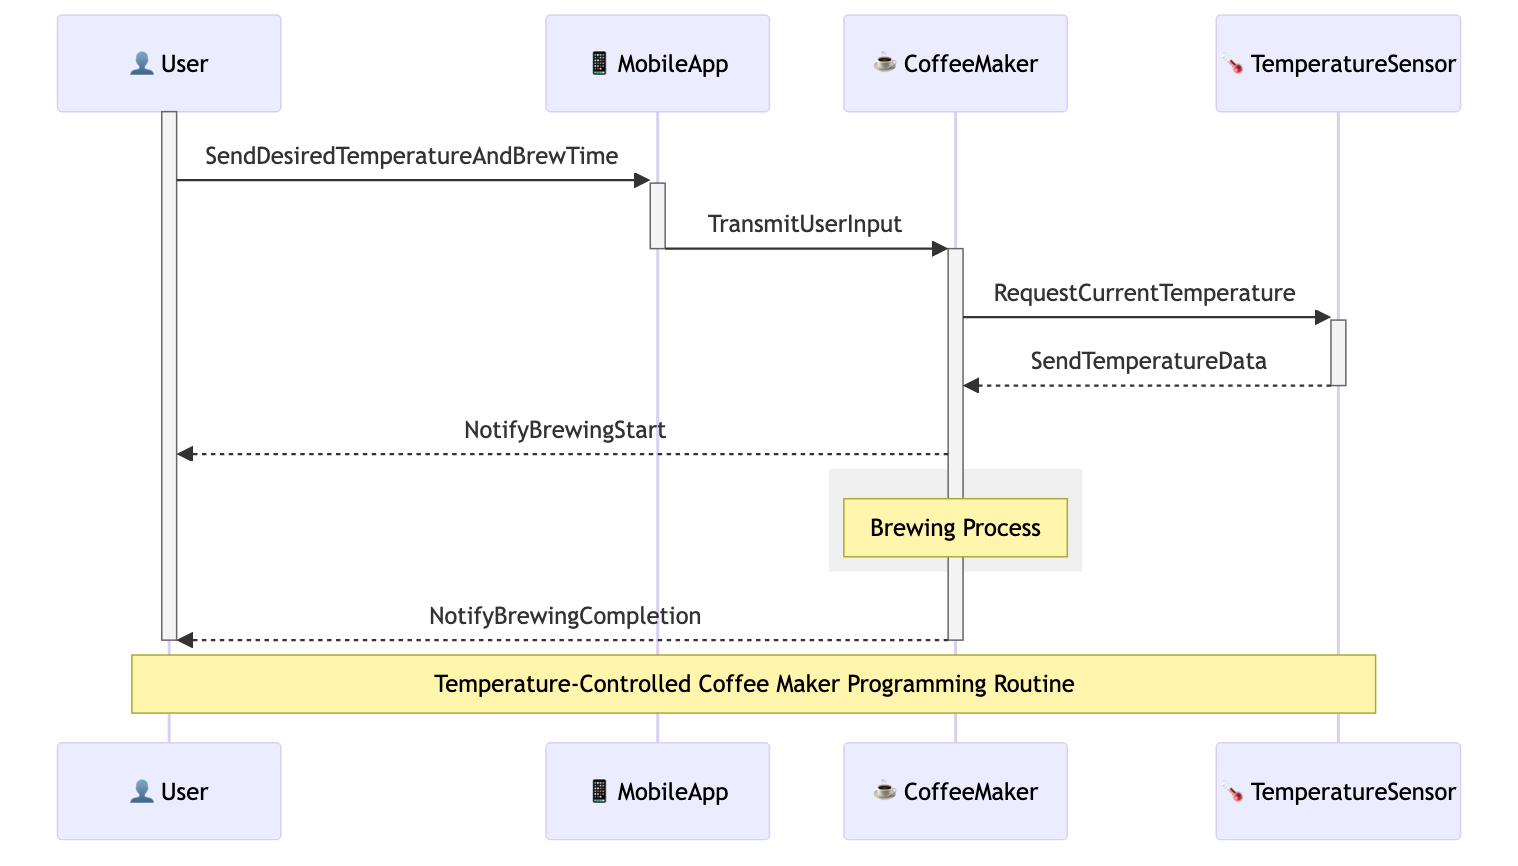What is the first action the User performs? The diagram starts with the User sending desired temperature and brew time using the MobileApp, which is the first message in the sequence.
Answer: SendDesiredTemperatureAndBrewTime How many actors are involved in this diagram? The diagram lists four actors: User, CoffeeMaker, MobileApp, and TemperatureSensor. Counting these gives a total of four actors.
Answer: Four What does the CoffeeMaker do after receiving the user input? After the CoffeeMaker receives the user input, it requests the current temperature from the TemperatureSensor. This is the next step after receiving input.
Answer: RequestCurrentTemperature What does the TemperatureSensor send back to the CoffeeMaker? The TemperatureSensor sends the current temperature data back to the CoffeeMaker after it is queried for the current temperature.
Answer: SendTemperatureData What information does the CoffeeMaker provide to the User during the brewing process? The CoffeeMaker notifies the User twice: once when the brewing starts and once when the brewing is completed. These notifications are critical for user awareness.
Answer: NotifyBrewingStart, NotifyBrewingCompletion What lifecycle is represented in the diagram? The diagram illustrates two lifecycles: the UserSession, which represents the duration of User interaction, and the CoffeeBrewingSession, which describes the coffee brewing process.
Answer: UserSession, CoffeeBrewingSession What triggers the NotifyBrewingStart message? The NotifyBrewingStart message is triggered after the CoffeeMaker has received the current temperature data and is ready to start brewing coffee. It indicates the transition from preparation to the brewing process.
Answer: Receipt of temperature data Which participant receives the first notification? The first notification, NotifyBrewingStart, is sent to the User once the brewing process begins, indicating that the User is the recipient of the first notification related to brewing.
Answer: User In what format is the brewing process represented in the diagram? The brewing process is represented within a rectangular box (rect) illustrating that it is an ongoing activity during which the CoffeeMaker works to brew the coffee.
Answer: Rectangular box 